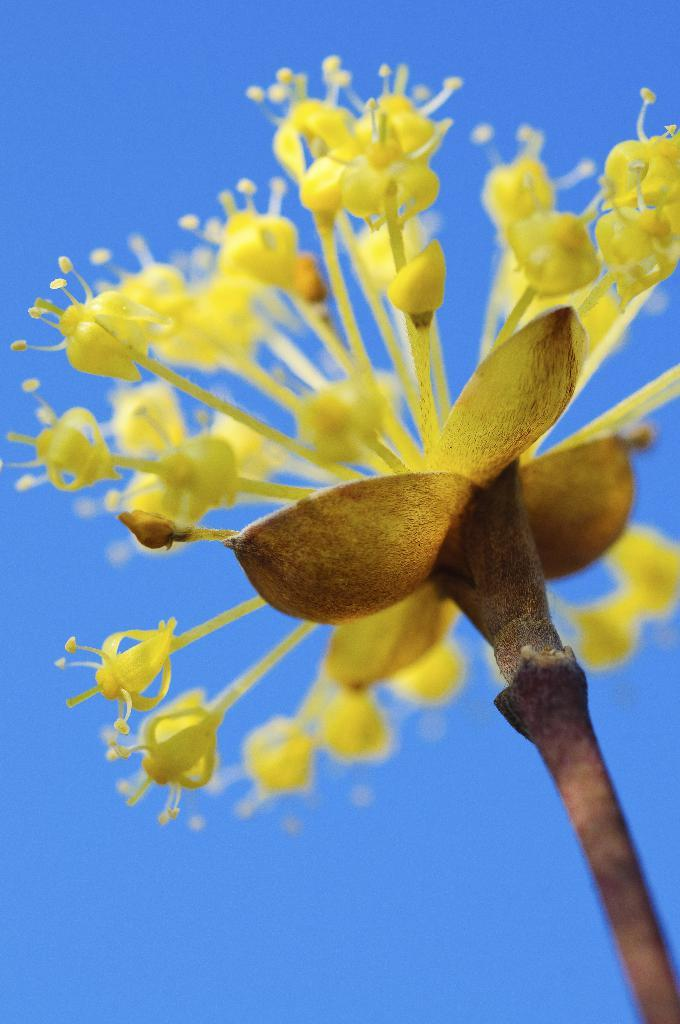What is the main subject of the picture? There is a flower in the picture. What is the color of the sky in the picture? The sky is blue in the picture. What invention does the daughter hold in her hands in the picture? There is no daughter or invention present in the picture; it only features a flower and a blue sky. 